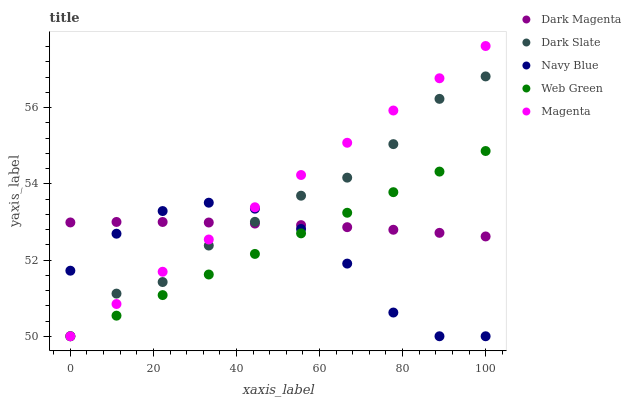Does Navy Blue have the minimum area under the curve?
Answer yes or no. Yes. Does Magenta have the maximum area under the curve?
Answer yes or no. Yes. Does Dark Magenta have the minimum area under the curve?
Answer yes or no. No. Does Dark Magenta have the maximum area under the curve?
Answer yes or no. No. Is Magenta the smoothest?
Answer yes or no. Yes. Is Navy Blue the roughest?
Answer yes or no. Yes. Is Dark Magenta the smoothest?
Answer yes or no. No. Is Dark Magenta the roughest?
Answer yes or no. No. Does Dark Slate have the lowest value?
Answer yes or no. Yes. Does Dark Magenta have the lowest value?
Answer yes or no. No. Does Magenta have the highest value?
Answer yes or no. Yes. Does Dark Magenta have the highest value?
Answer yes or no. No. Does Navy Blue intersect Dark Magenta?
Answer yes or no. Yes. Is Navy Blue less than Dark Magenta?
Answer yes or no. No. Is Navy Blue greater than Dark Magenta?
Answer yes or no. No. 